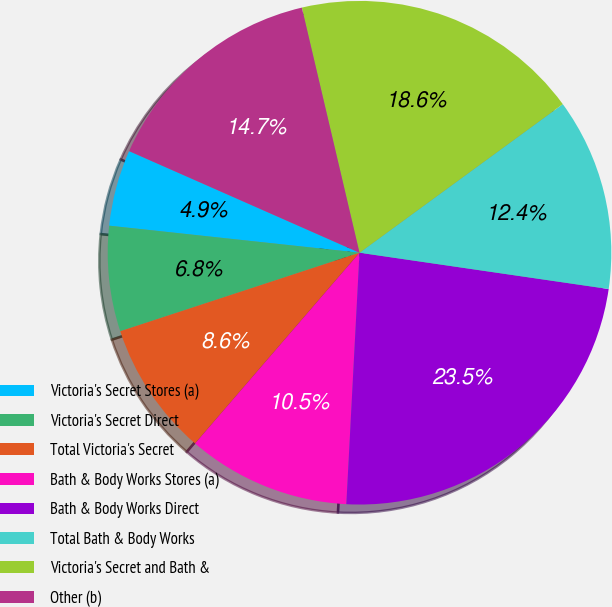Convert chart. <chart><loc_0><loc_0><loc_500><loc_500><pie_chart><fcel>Victoria's Secret Stores (a)<fcel>Victoria's Secret Direct<fcel>Total Victoria's Secret<fcel>Bath & Body Works Stores (a)<fcel>Bath & Body Works Direct<fcel>Total Bath & Body Works<fcel>Victoria's Secret and Bath &<fcel>Other (b)<nl><fcel>4.9%<fcel>6.76%<fcel>8.63%<fcel>10.49%<fcel>23.53%<fcel>12.35%<fcel>18.63%<fcel>14.71%<nl></chart> 